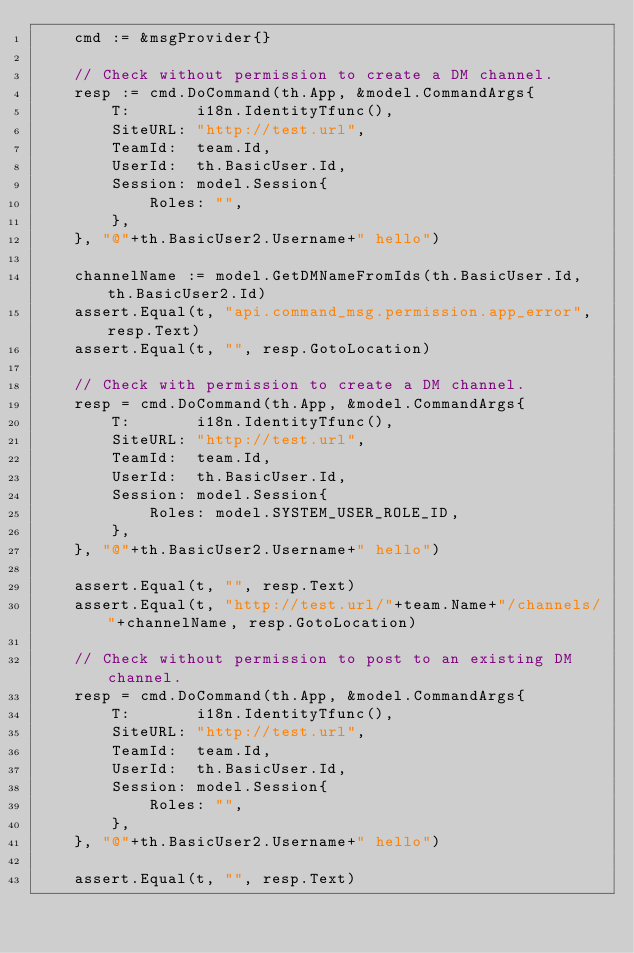<code> <loc_0><loc_0><loc_500><loc_500><_Go_>	cmd := &msgProvider{}

	// Check without permission to create a DM channel.
	resp := cmd.DoCommand(th.App, &model.CommandArgs{
		T:       i18n.IdentityTfunc(),
		SiteURL: "http://test.url",
		TeamId:  team.Id,
		UserId:  th.BasicUser.Id,
		Session: model.Session{
			Roles: "",
		},
	}, "@"+th.BasicUser2.Username+" hello")

	channelName := model.GetDMNameFromIds(th.BasicUser.Id, th.BasicUser2.Id)
	assert.Equal(t, "api.command_msg.permission.app_error", resp.Text)
	assert.Equal(t, "", resp.GotoLocation)

	// Check with permission to create a DM channel.
	resp = cmd.DoCommand(th.App, &model.CommandArgs{
		T:       i18n.IdentityTfunc(),
		SiteURL: "http://test.url",
		TeamId:  team.Id,
		UserId:  th.BasicUser.Id,
		Session: model.Session{
			Roles: model.SYSTEM_USER_ROLE_ID,
		},
	}, "@"+th.BasicUser2.Username+" hello")

	assert.Equal(t, "", resp.Text)
	assert.Equal(t, "http://test.url/"+team.Name+"/channels/"+channelName, resp.GotoLocation)

	// Check without permission to post to an existing DM channel.
	resp = cmd.DoCommand(th.App, &model.CommandArgs{
		T:       i18n.IdentityTfunc(),
		SiteURL: "http://test.url",
		TeamId:  team.Id,
		UserId:  th.BasicUser.Id,
		Session: model.Session{
			Roles: "",
		},
	}, "@"+th.BasicUser2.Username+" hello")

	assert.Equal(t, "", resp.Text)</code> 